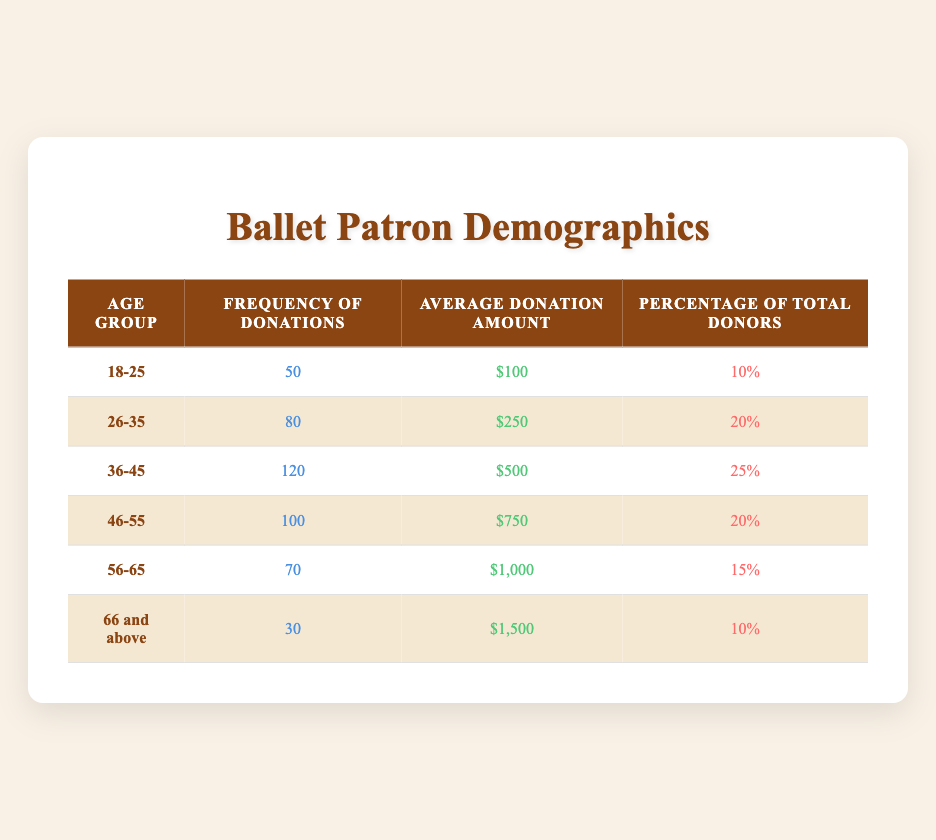What is the frequency of donations from the 36-45 age group? Referring to the table, the frequency of donations for the 36-45 age group is provided in the corresponding cell. It states a frequency of 120 donations.
Answer: 120 Which age group has the highest average donation amount? The table lists the average donation amounts for each age group. On comparing, the age group 66 and above shows the highest average donation amount of $1,500.
Answer: 66 and above What is the total frequency of donations from the age groups 18-25 and 26-35 combined? The frequency for the 18-25 age group is 50, and for the 26-35 age group, it is 80. Summing these values gives 50 + 80 = 130.
Answer: 130 Is the percentage of total donors for the 56-65 age group greater than 15%? The table indicates that the percentage of total donors for the 56-65 age group is exactly 15%. Therefore, it is not greater than 15%.
Answer: No What is the average donation amount of the age group with the highest frequency of donations? From the table, the age group with the highest frequency of donations is 36-45, which has an average donation amount of $500.
Answer: $500 If we consider only the age groups 46-55 and 56-65, what is the average frequency of donations for these groups? The table shows that the frequency for 46-55 is 100 and for 56-65 is 70. Adding these two frequencies gives 100 + 70 = 170, and dividing by 2 (the number of groups) gives an average of 85.
Answer: 85 Which age group contributes 20% of the total donors? The table indicates two age groups with a percentage of total donors equal to 20%: 26-35 and 46-55.
Answer: 26-35 and 46-55 What is the difference in average donation amounts between the 56-65 and the 66 and above age groups? The average donation amount for 56-65 is $1,000, and for 66 and above, it is $1,500. The difference is $1,500 - $1,000 = $500.
Answer: $500 